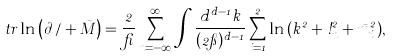<formula> <loc_0><loc_0><loc_500><loc_500>t r \ln { \left ( \partial \, \slash + \bar { M } \right ) } = \frac { 2 } { \beta } \sum _ { n = - \infty } ^ { \infty } \int \frac { d ^ { d - 1 } { k } } { ( 2 \pi ) ^ { d - 1 } } \sum _ { i = 1 } ^ { 2 } \ln { \left ( { k } ^ { 2 } + \omega _ { n } ^ { 2 } + \bar { m } _ { i } ^ { 2 } \right ) } ,</formula> 